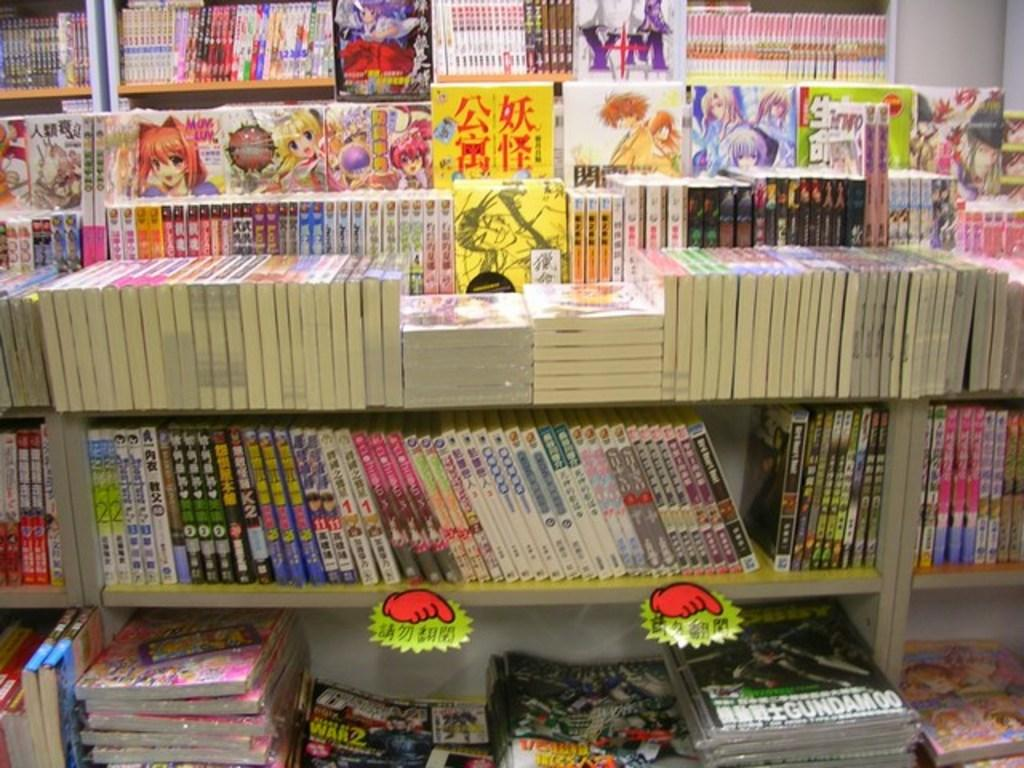<image>
Relay a brief, clear account of the picture shown. A lot of books on shelves the one on the floor is gundam. 